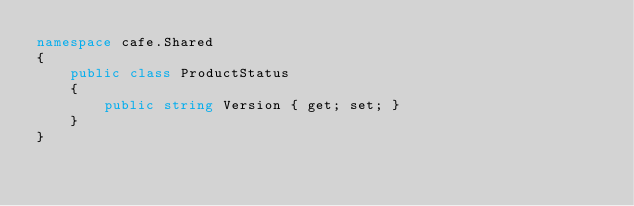Convert code to text. <code><loc_0><loc_0><loc_500><loc_500><_C#_>namespace cafe.Shared
{
    public class ProductStatus
    {
        public string Version { get; set; }
    }
}</code> 